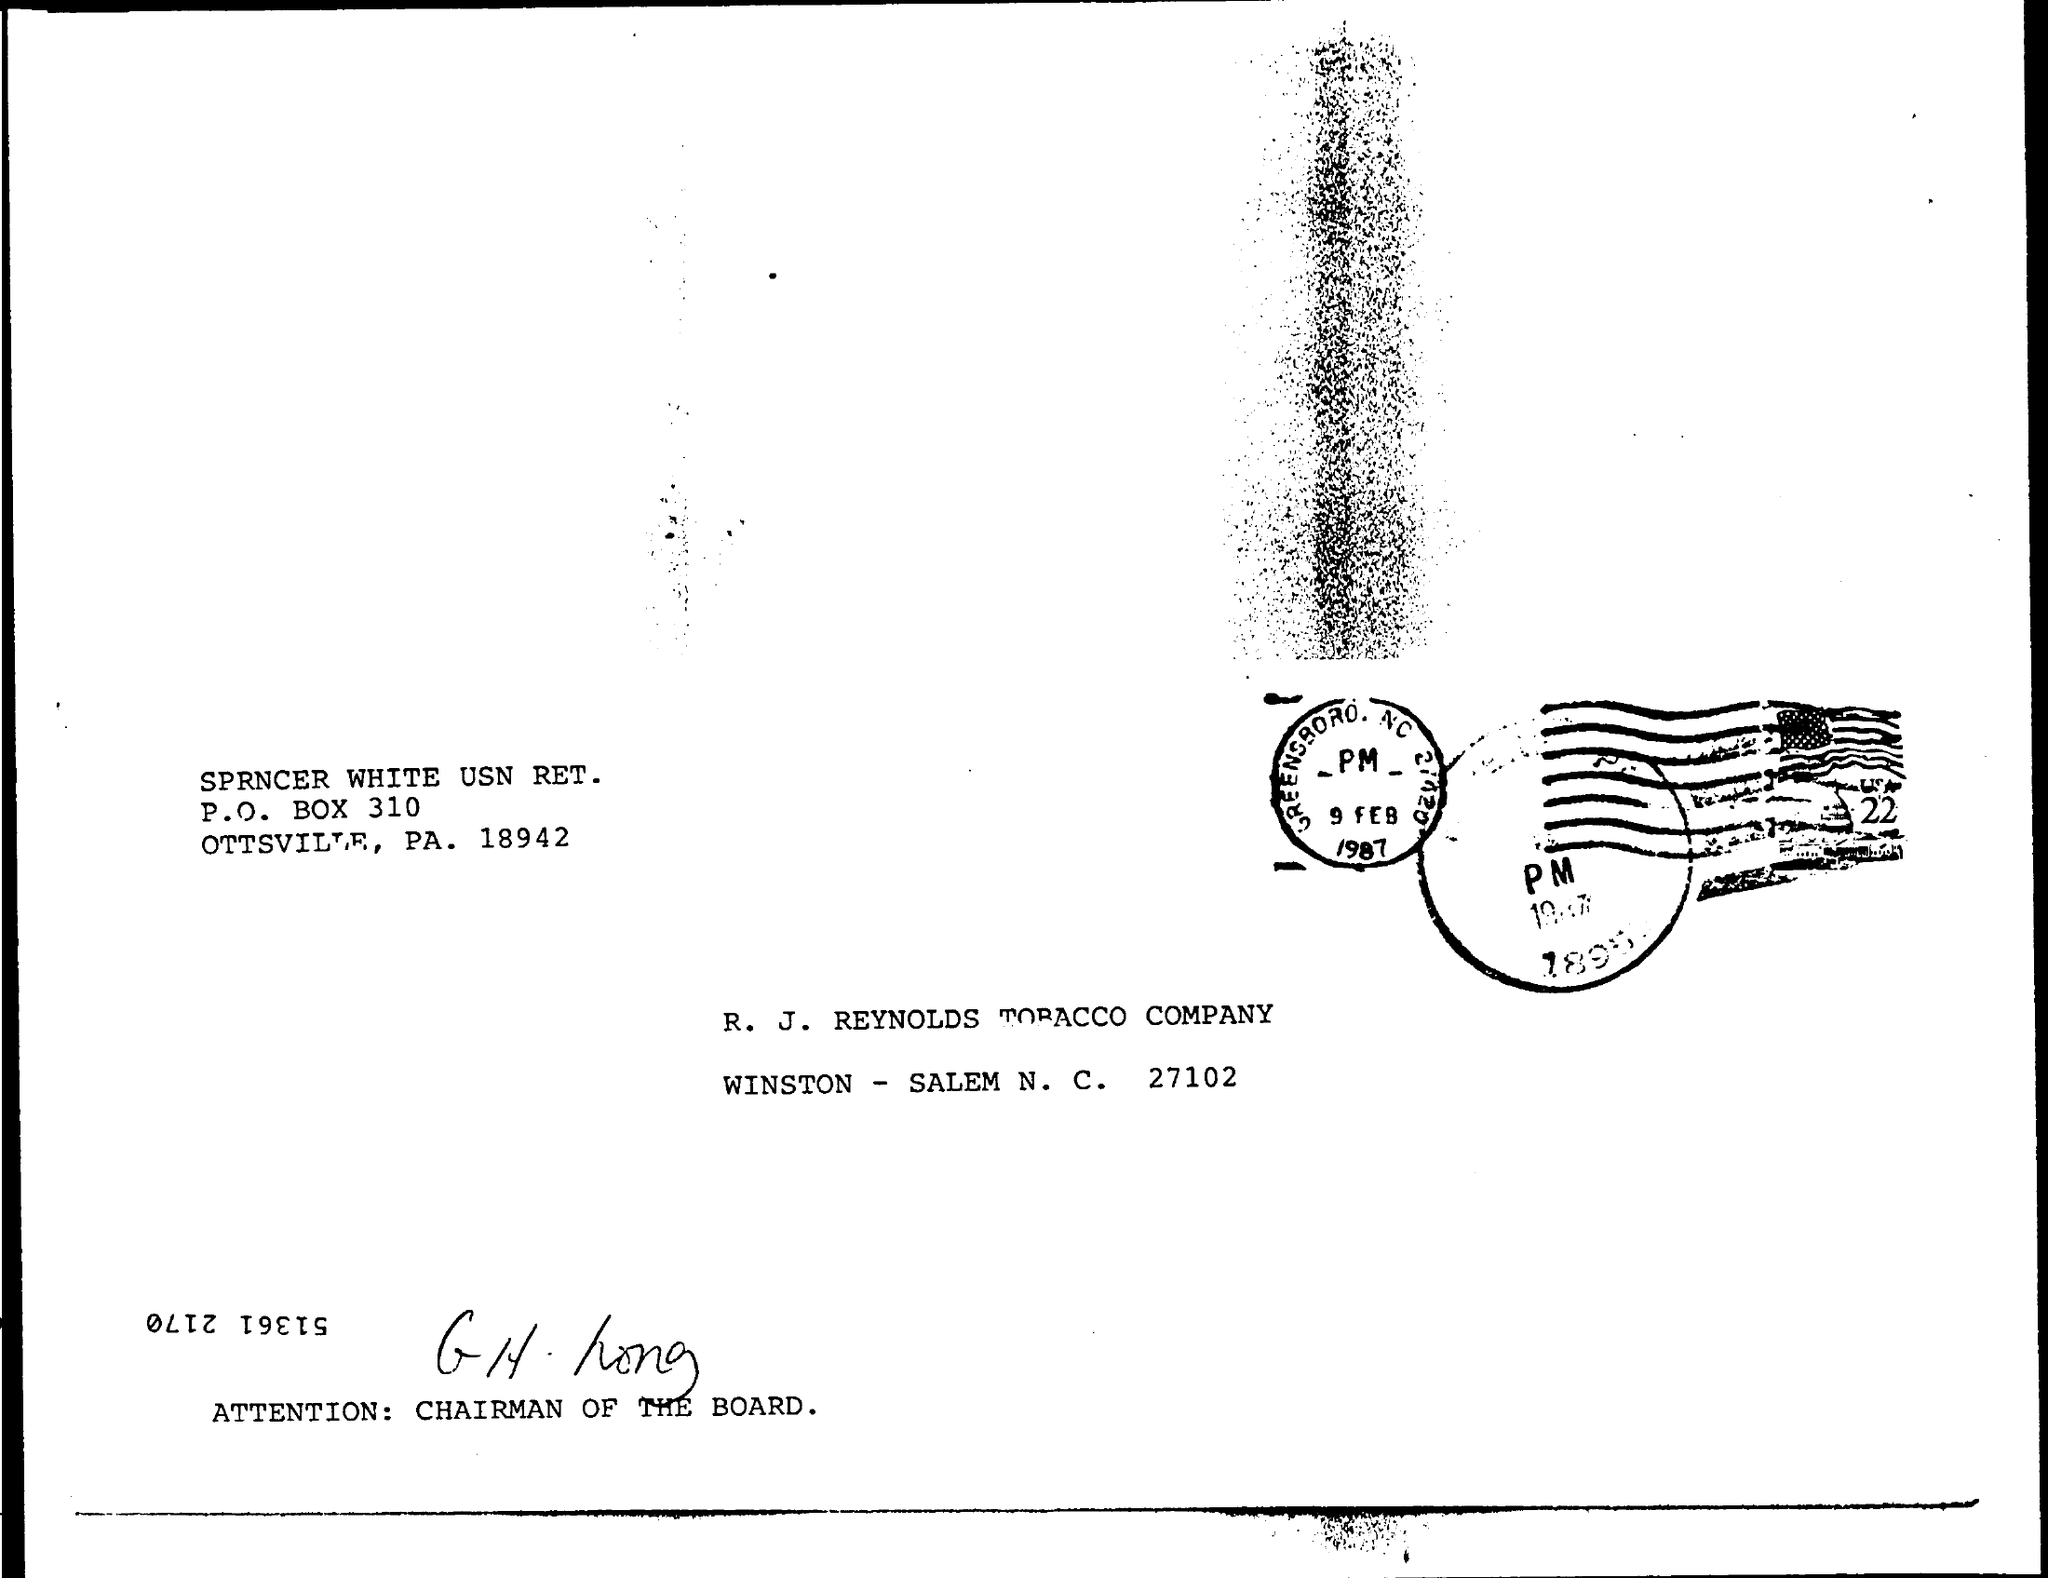What date is written on the stamp?
Give a very brief answer. 9 FEB 1987. 